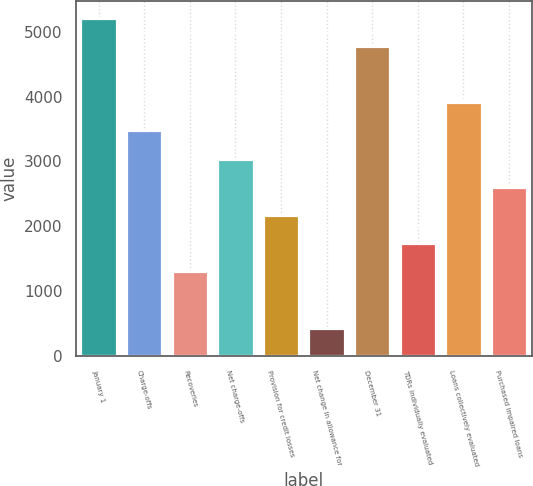Convert chart to OTSL. <chart><loc_0><loc_0><loc_500><loc_500><bar_chart><fcel>January 1<fcel>Charge-offs<fcel>Recoveries<fcel>Net charge-offs<fcel>Provision for credit losses<fcel>Net change in allowance for<fcel>December 31<fcel>TDRs individually evaluated<fcel>Loans collectively evaluated<fcel>Purchased impaired loans<nl><fcel>5215.93<fcel>3478.01<fcel>1305.61<fcel>3043.53<fcel>2174.57<fcel>436.65<fcel>4781.45<fcel>1740.09<fcel>3912.49<fcel>2609.05<nl></chart> 